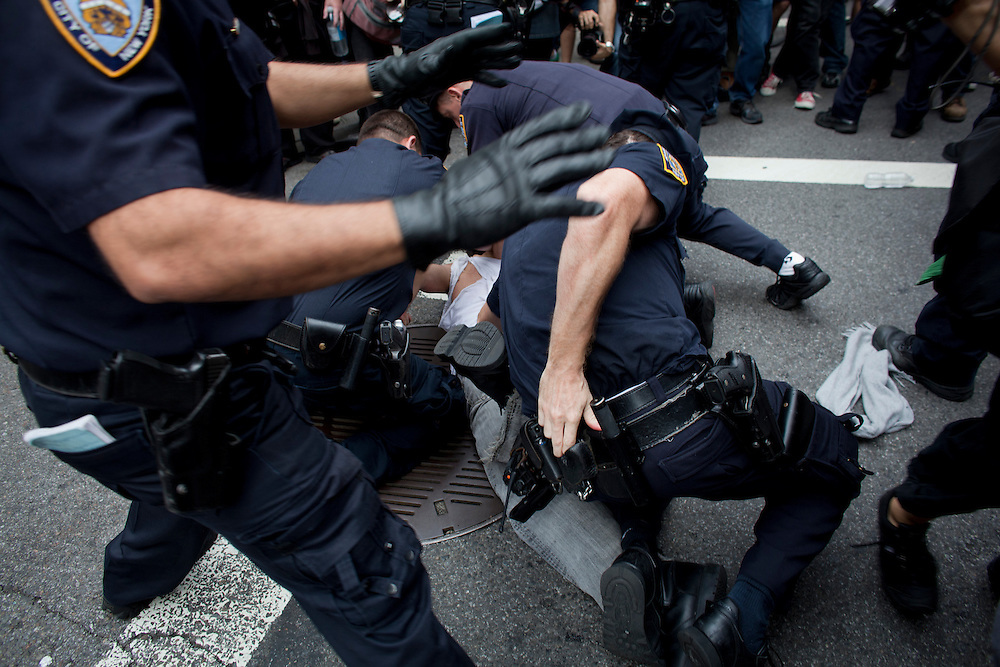Considering the attire of the individual being subdued, what might have been the nature of the incident leading up to this moment? Based on the casual attire of the individual being subdued, which does not include any specific uniform or work-related garb, it indicates that the incident may have been abrupt or unplanned. The person's clothing, which lacks any protective or strategic elements, suggests they were likely not prepared for a confrontation or a premeditated act. This implies that the situation likely developed out of everyday occurrences rather than a calculated or professional scenario. The absence of any specialized equipment on the subdued individual reinforces the idea that they did not anticipate an altercation or intense situation to arise. 